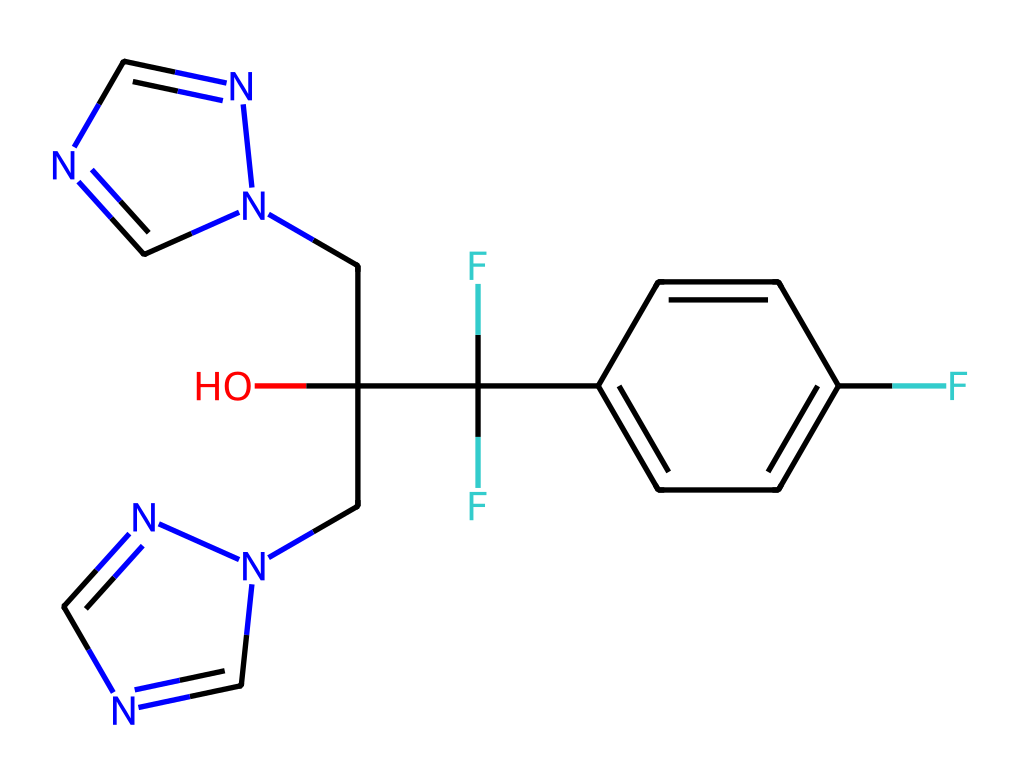What is the molecular formula of fluconazole? The SMILES notation provides the connectivity of the atoms in the chemical, allowing us to count the number of each atom type. By interpreting the structure, we can determine it consists of 18 carbon (C), 20 hydrogen (H), 2 nitrogen (N), 4 fluorine (F), and 2 oxygen (O) atoms, leading to the formula C18H20F4N2O2.
Answer: C18H20F4N2O2 How many rings are present in the structure? The SMILES represents the presence of two distinct fused aromatic rings, marked by 'n1' which indicates the start of a ring where nitrogen atoms are utilized. Counting these rings shows there are two in total.
Answer: 2 What type of functional groups are present in fluconazole? Analysis of the SMILES reveals that functional groups include hydroxyl (-OH) and trifluoromethyl (-CF3) due to the presence of the oxygen atom bonded to carbon and the three fluorine atoms bonded to another carbon.
Answer: hydroxyl, trifluoromethyl How many fluorine atoms are in fluconazole? The 'C(F)(F)' part of the SMILES indicates the trifluoromethyl group, which contains three fluorine atoms attached to one carbon. Counting these gives a total of four fluorine atoms present in the compound.
Answer: 4 What is the possible biological target of fluconazole? Understanding fluconazole's action involves its structure, primarily affecting the synthesis of ergosterol in fungal cell membranes due to the presence of the nitrogen-containing aromatic rings. This specific targeting indicates that fluconazole is a fungal cell membrane disruptor.
Answer: ergosterol What is the significance of the nitrogen atoms in fluconazole? The nitrogen atoms (as indicated by 'n' in the SMILES) are critical in contributing to the antifungal activity of fluconazole, primarily due to their role in disrupting the function of fungal enzymes necessary for the cell wall synthesis, leading to increased permeability.
Answer: antifungal activity 